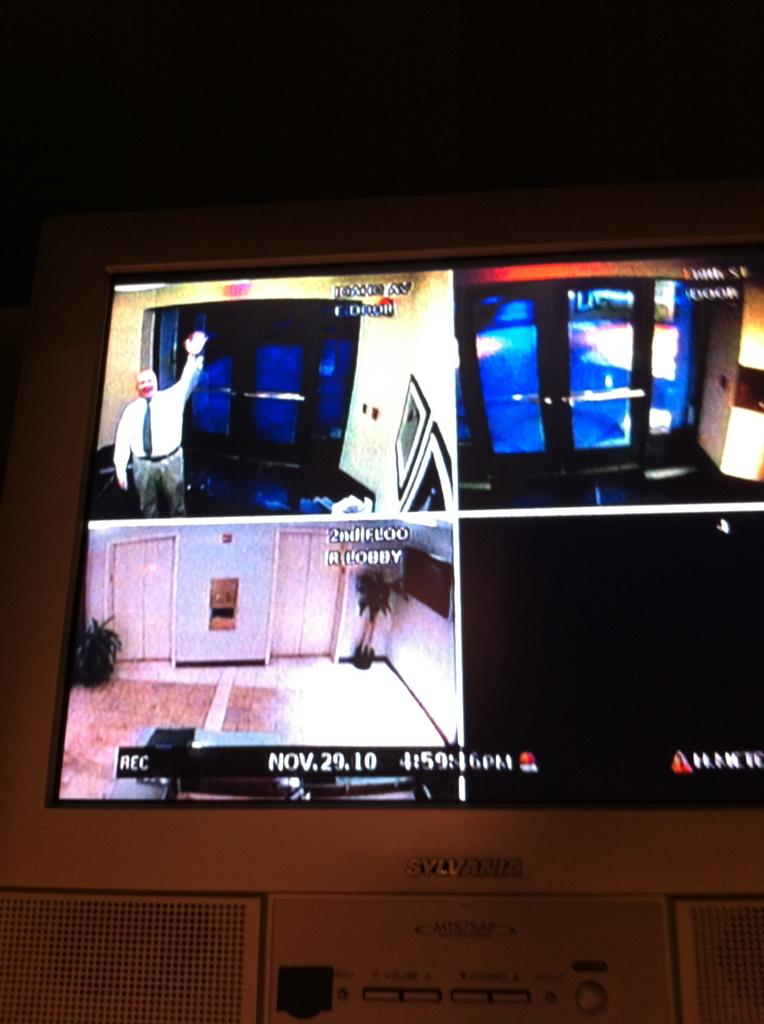<image>
Render a clear and concise summary of the photo. A security camera with the date "Nov.29.10" depicted at the bottom. 